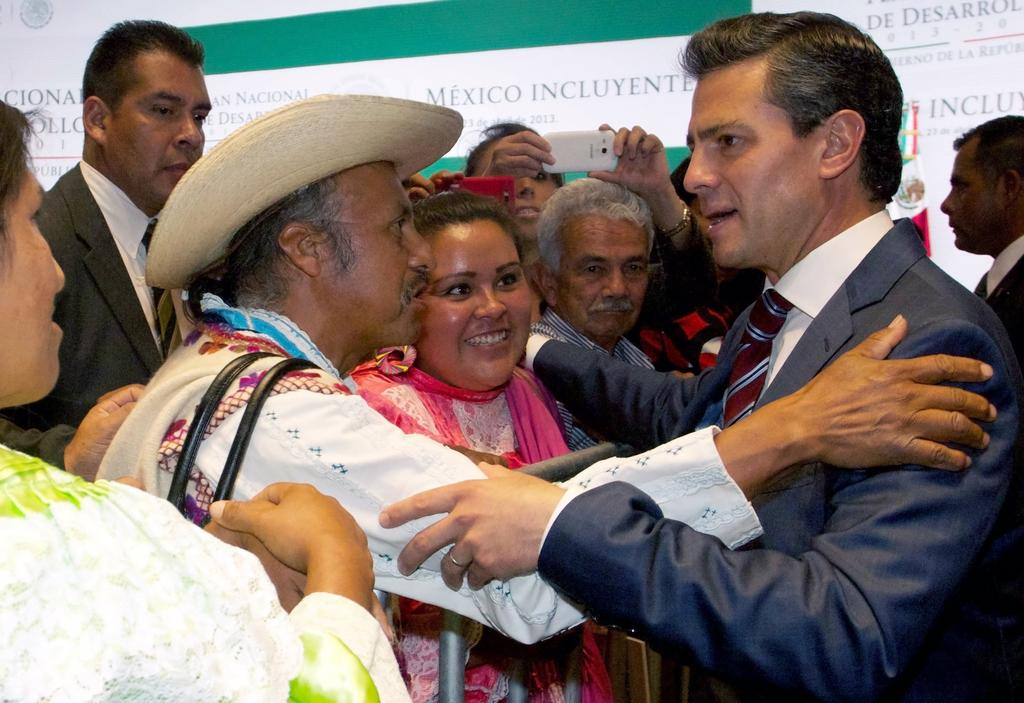How many men are present in the image? There are two men in the image. What are the two men doing in the image? The two men are holding each other's hands. What can be seen in the background of the image? There are people in the background of the image, and they are taking pictures with their mobile devices. What else is visible in the background of the image? There are banners visible in the background of the image. What type of border is visible in the image? There is no border visible in the image. Can you tell me how many family members are present in the image? The image does not show any family members; it only features two men holding hands. 